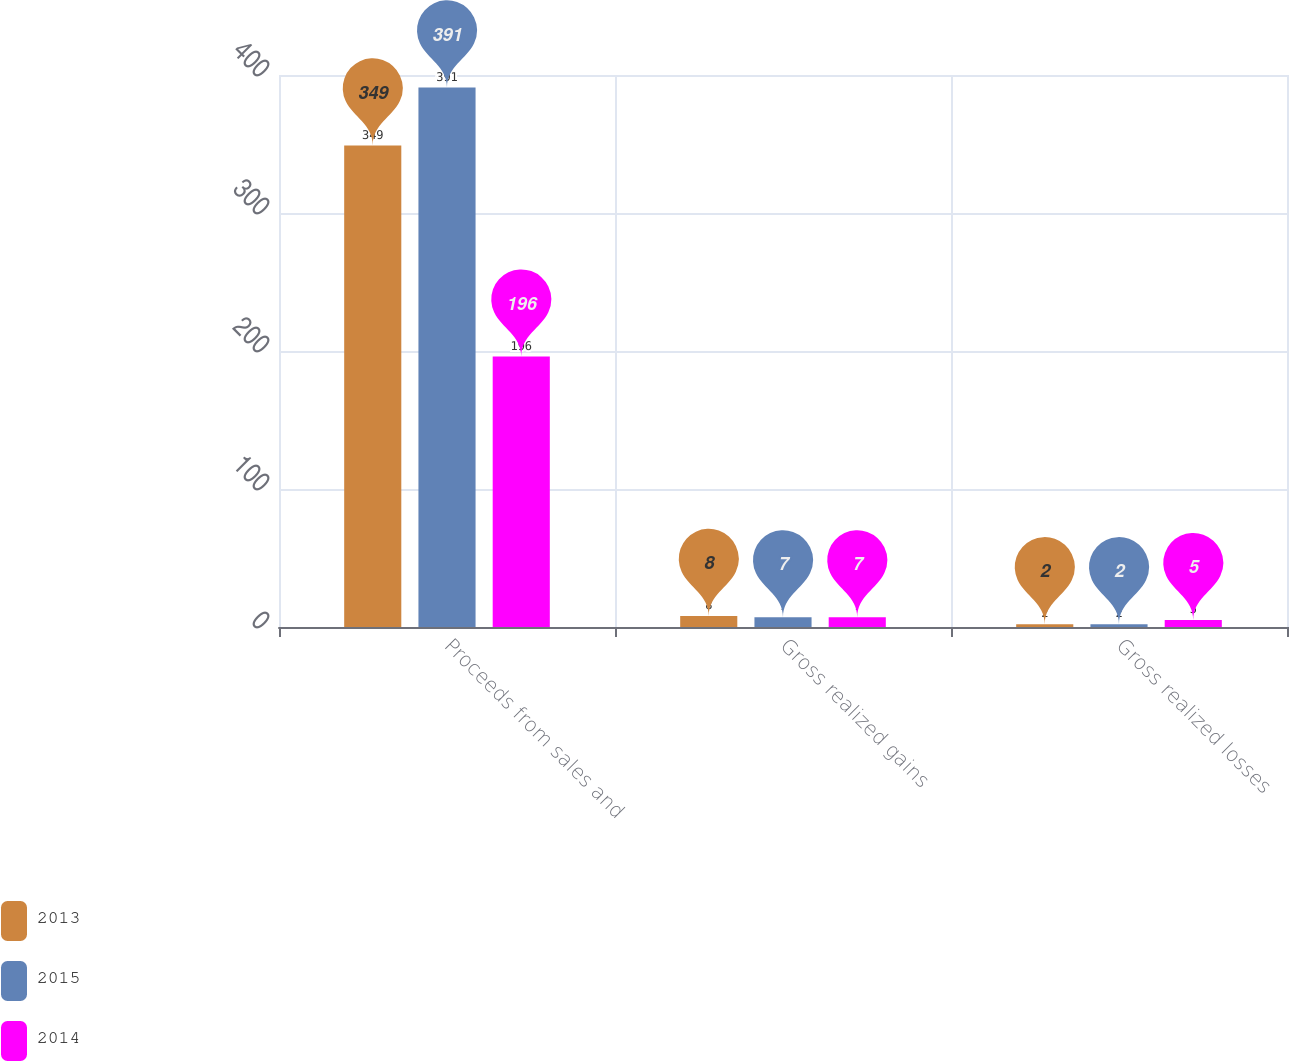Convert chart to OTSL. <chart><loc_0><loc_0><loc_500><loc_500><stacked_bar_chart><ecel><fcel>Proceeds from sales and<fcel>Gross realized gains<fcel>Gross realized losses<nl><fcel>2013<fcel>349<fcel>8<fcel>2<nl><fcel>2015<fcel>391<fcel>7<fcel>2<nl><fcel>2014<fcel>196<fcel>7<fcel>5<nl></chart> 